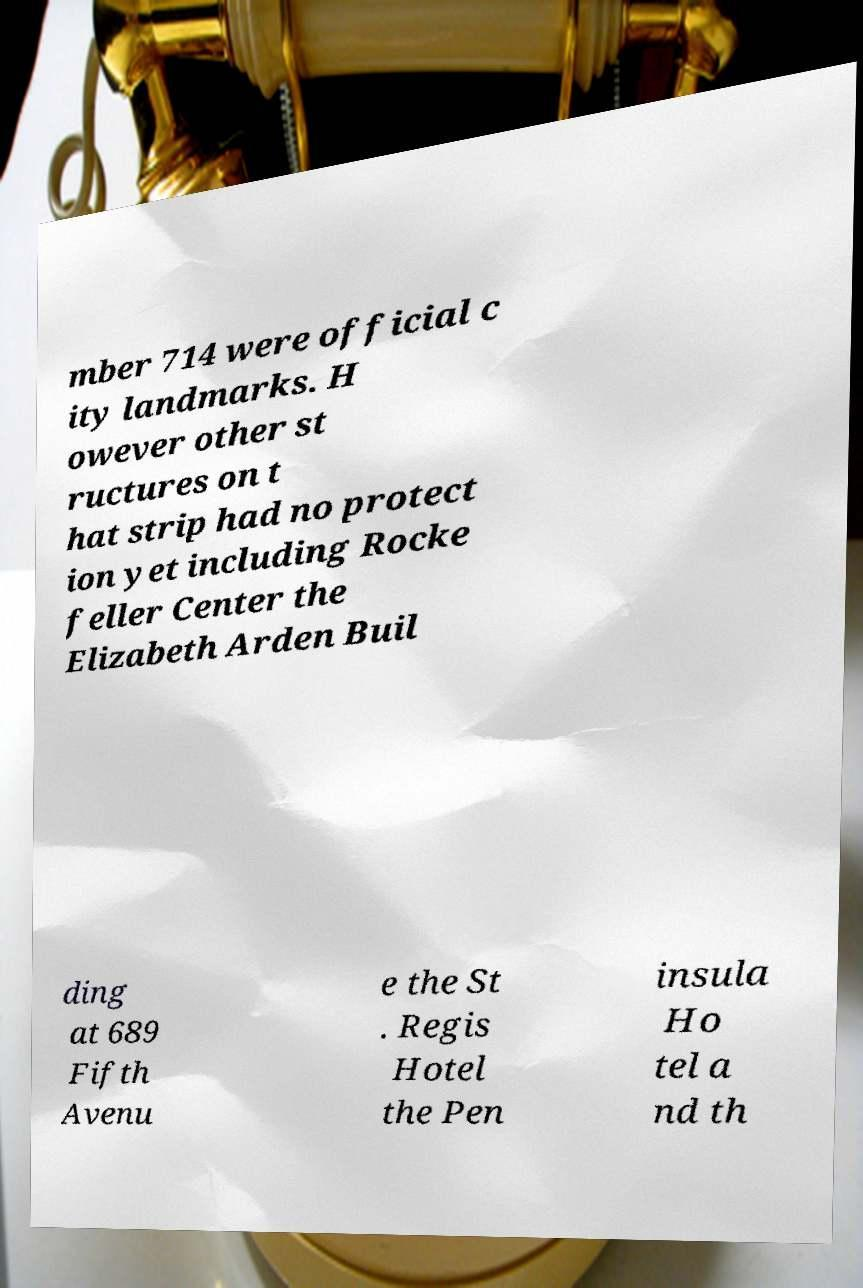I need the written content from this picture converted into text. Can you do that? mber 714 were official c ity landmarks. H owever other st ructures on t hat strip had no protect ion yet including Rocke feller Center the Elizabeth Arden Buil ding at 689 Fifth Avenu e the St . Regis Hotel the Pen insula Ho tel a nd th 